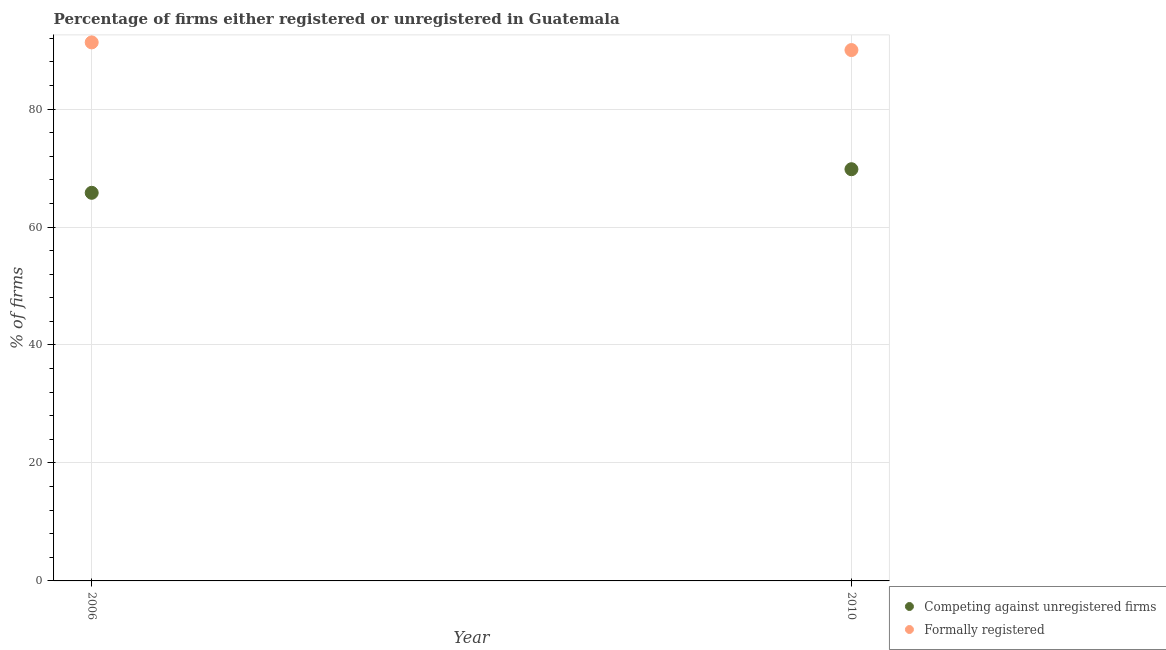How many different coloured dotlines are there?
Provide a succinct answer. 2. Is the number of dotlines equal to the number of legend labels?
Your answer should be very brief. Yes. What is the percentage of formally registered firms in 2006?
Offer a terse response. 91.3. Across all years, what is the maximum percentage of formally registered firms?
Ensure brevity in your answer.  91.3. In which year was the percentage of formally registered firms maximum?
Provide a short and direct response. 2006. In which year was the percentage of formally registered firms minimum?
Give a very brief answer. 2010. What is the total percentage of formally registered firms in the graph?
Provide a succinct answer. 181.3. What is the difference between the percentage of formally registered firms in 2006 and that in 2010?
Offer a terse response. 1.3. What is the difference between the percentage of registered firms in 2010 and the percentage of formally registered firms in 2006?
Offer a very short reply. -21.5. What is the average percentage of formally registered firms per year?
Ensure brevity in your answer.  90.65. In the year 2010, what is the difference between the percentage of registered firms and percentage of formally registered firms?
Provide a succinct answer. -20.2. In how many years, is the percentage of registered firms greater than 56 %?
Keep it short and to the point. 2. What is the ratio of the percentage of formally registered firms in 2006 to that in 2010?
Offer a very short reply. 1.01. In how many years, is the percentage of formally registered firms greater than the average percentage of formally registered firms taken over all years?
Keep it short and to the point. 1. Does the percentage of formally registered firms monotonically increase over the years?
Give a very brief answer. No. How many years are there in the graph?
Make the answer very short. 2. What is the difference between two consecutive major ticks on the Y-axis?
Provide a succinct answer. 20. Are the values on the major ticks of Y-axis written in scientific E-notation?
Ensure brevity in your answer.  No. Does the graph contain grids?
Offer a terse response. Yes. How are the legend labels stacked?
Your answer should be very brief. Vertical. What is the title of the graph?
Ensure brevity in your answer.  Percentage of firms either registered or unregistered in Guatemala. What is the label or title of the X-axis?
Your answer should be compact. Year. What is the label or title of the Y-axis?
Ensure brevity in your answer.  % of firms. What is the % of firms of Competing against unregistered firms in 2006?
Ensure brevity in your answer.  65.8. What is the % of firms of Formally registered in 2006?
Give a very brief answer. 91.3. What is the % of firms in Competing against unregistered firms in 2010?
Give a very brief answer. 69.8. What is the % of firms in Formally registered in 2010?
Keep it short and to the point. 90. Across all years, what is the maximum % of firms in Competing against unregistered firms?
Make the answer very short. 69.8. Across all years, what is the maximum % of firms in Formally registered?
Provide a succinct answer. 91.3. Across all years, what is the minimum % of firms in Competing against unregistered firms?
Offer a terse response. 65.8. What is the total % of firms in Competing against unregistered firms in the graph?
Provide a succinct answer. 135.6. What is the total % of firms of Formally registered in the graph?
Keep it short and to the point. 181.3. What is the difference between the % of firms of Competing against unregistered firms in 2006 and the % of firms of Formally registered in 2010?
Provide a short and direct response. -24.2. What is the average % of firms of Competing against unregistered firms per year?
Make the answer very short. 67.8. What is the average % of firms in Formally registered per year?
Keep it short and to the point. 90.65. In the year 2006, what is the difference between the % of firms of Competing against unregistered firms and % of firms of Formally registered?
Provide a succinct answer. -25.5. In the year 2010, what is the difference between the % of firms in Competing against unregistered firms and % of firms in Formally registered?
Offer a terse response. -20.2. What is the ratio of the % of firms in Competing against unregistered firms in 2006 to that in 2010?
Offer a terse response. 0.94. What is the ratio of the % of firms of Formally registered in 2006 to that in 2010?
Keep it short and to the point. 1.01. What is the difference between the highest and the second highest % of firms of Competing against unregistered firms?
Provide a short and direct response. 4. 